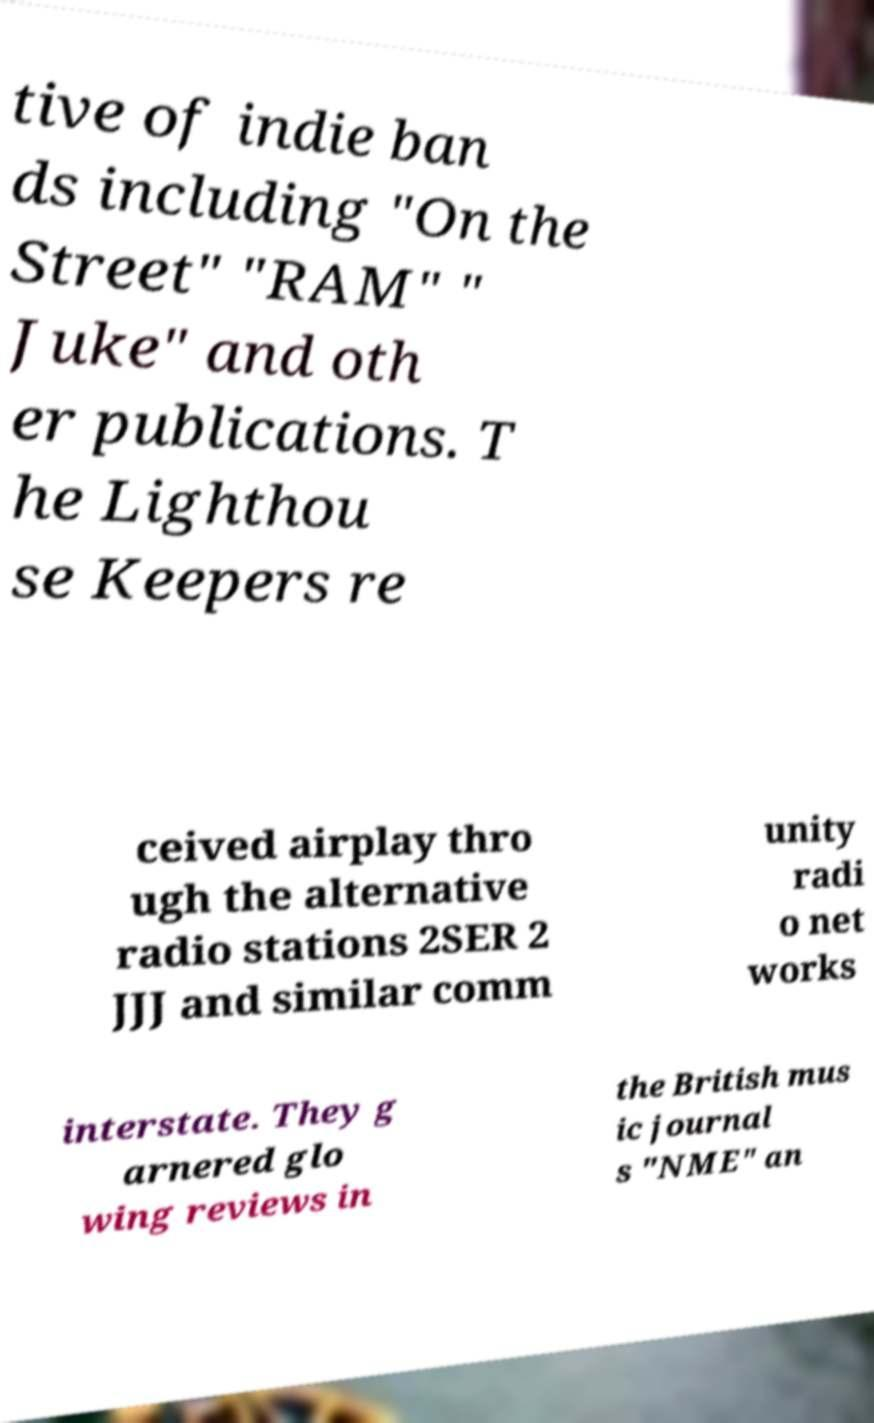Can you accurately transcribe the text from the provided image for me? tive of indie ban ds including "On the Street" "RAM" " Juke" and oth er publications. T he Lighthou se Keepers re ceived airplay thro ugh the alternative radio stations 2SER 2 JJJ and similar comm unity radi o net works interstate. They g arnered glo wing reviews in the British mus ic journal s "NME" an 